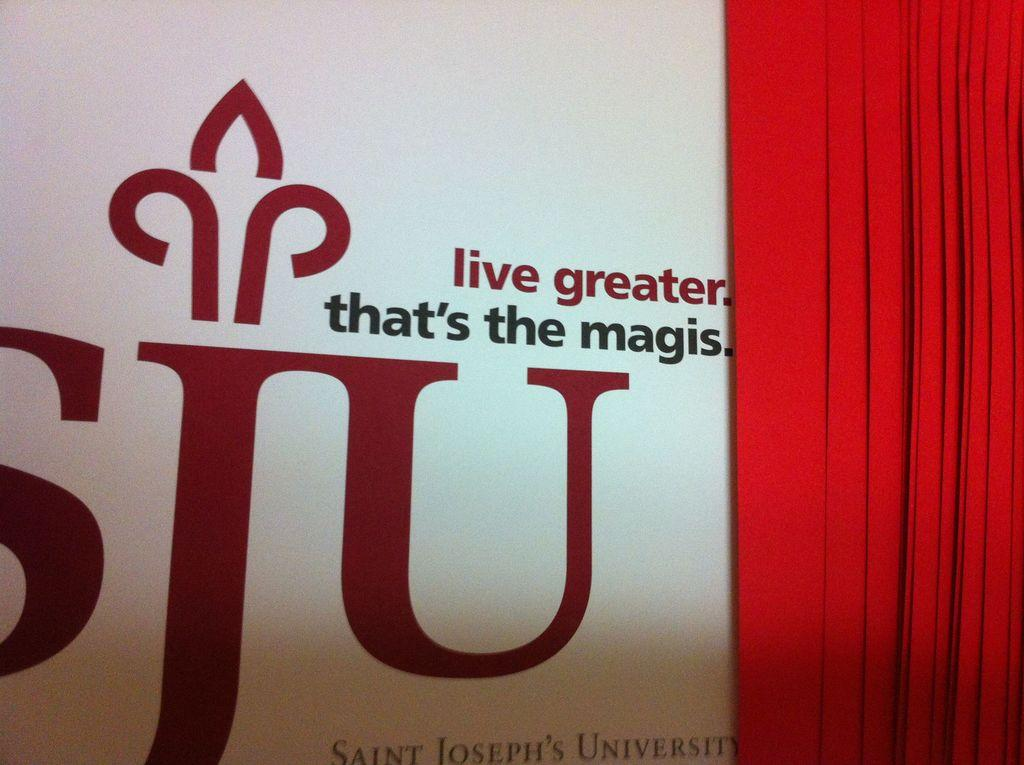<image>
Give a short and clear explanation of the subsequent image. A statement and logo from Saint Joseph's University is on the wall behind a curtain. 